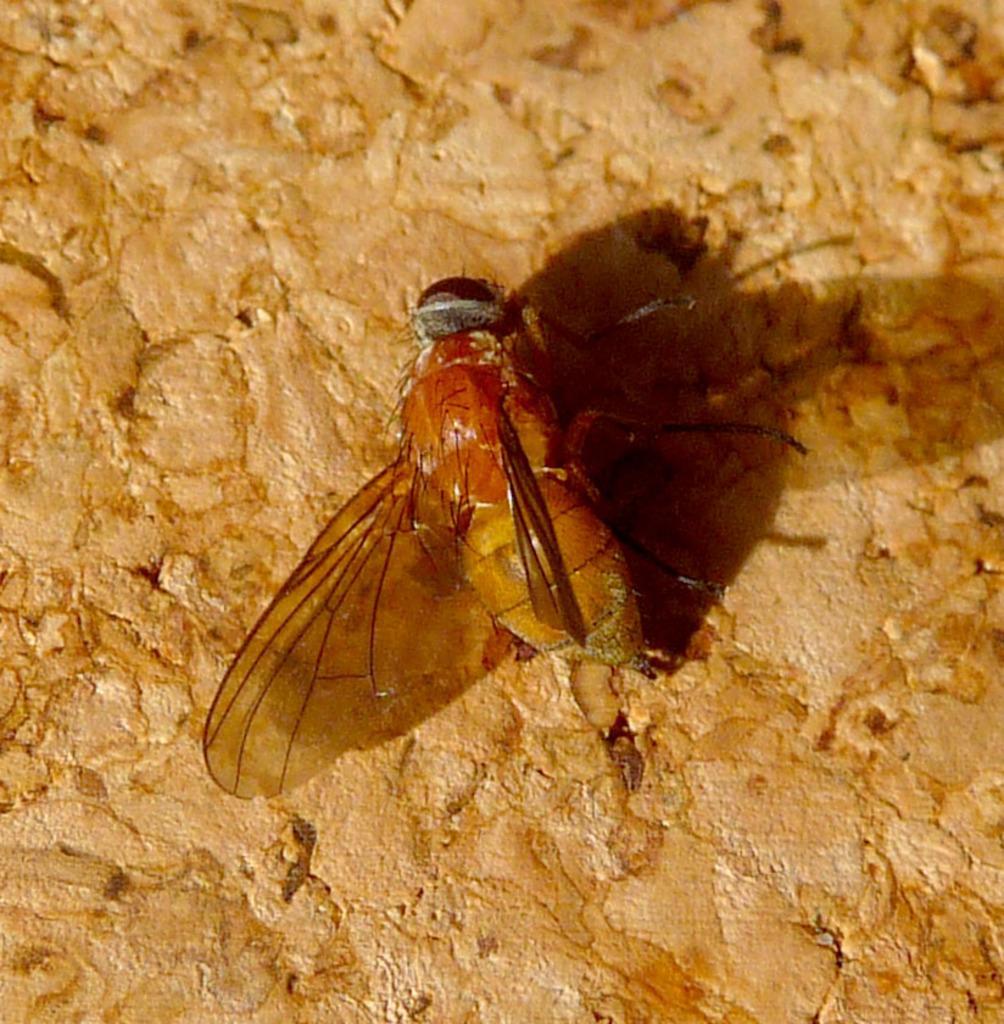In one or two sentences, can you explain what this image depicts? In this image we can see a honey bee on the brown color stone surface. 